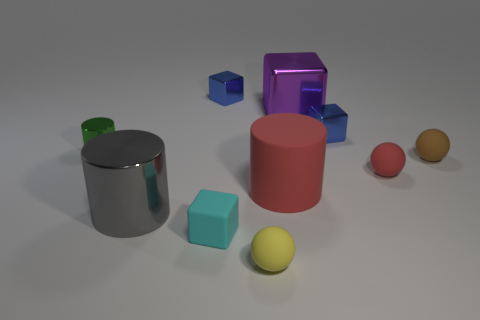The thing that is the same color as the rubber cylinder is what size?
Your answer should be compact. Small. What shape is the blue shiny object that is in front of the blue shiny block to the left of the big rubber cylinder?
Ensure brevity in your answer.  Cube. Are there fewer small metal cylinders than small rubber spheres?
Offer a terse response. Yes. What is the size of the metal thing that is on the left side of the small yellow matte ball and to the right of the big gray shiny thing?
Provide a succinct answer. Small. Does the yellow sphere have the same size as the green shiny cylinder?
Ensure brevity in your answer.  Yes. How many brown balls are right of the yellow rubber thing?
Give a very brief answer. 1. Is the number of big yellow metallic cylinders greater than the number of small blue shiny blocks?
Provide a short and direct response. No. What shape is the tiny object that is behind the small brown matte ball and on the right side of the red rubber cylinder?
Give a very brief answer. Cube. Is there a small brown rubber object?
Ensure brevity in your answer.  Yes. There is another large object that is the same shape as the large red object; what is it made of?
Make the answer very short. Metal. 